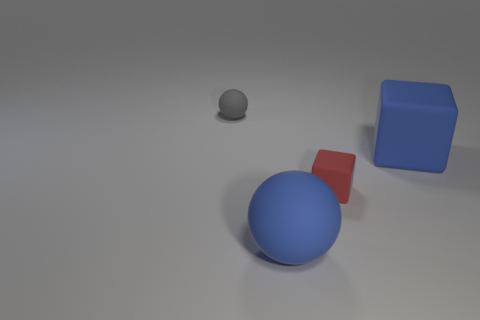Add 3 blocks. How many objects exist? 7 Subtract 0 red cylinders. How many objects are left? 4 Subtract all large rubber cubes. Subtract all red metallic objects. How many objects are left? 3 Add 2 blue matte cubes. How many blue matte cubes are left? 3 Add 3 red cylinders. How many red cylinders exist? 3 